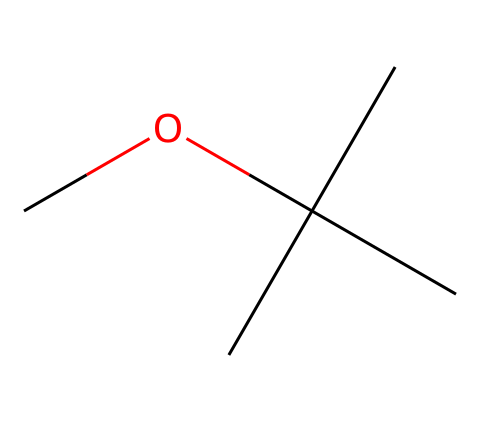What is the full name of this chemical? The SMILES representation "COC(C)(C)C" indicates a molecule with a central carbon atom connected to three other carbons and one oxygen atom. Identifying the functional group as an ether reveals it is methyl tert-butyl ether.
Answer: methyl tert-butyl ether How many carbon atoms are in this molecule? Analyzing the SMILES, there are four carbon atoms: one in the methoxy group (OCH3) and three connected to the central carbon (C(C)(C)). Therefore, a total of four carbons are present.
Answer: four What is the primary functional group here? The presence of the ether bond (R-O-R') in the structure, indicated by the oxygen bridging between carbon atoms, confirms the molecule's classification. Therefore, the primary functional group is ether.
Answer: ether What type of reaction can MTBE undergo with water? MTBE is only sparingly soluble in water due to its hydrophobic characteristics. In cases of spillage, it can lead to contamination but does not react chemically with water.
Answer: no significant reaction Is this compound considered a volatile organic compound (VOC)? MTBE has a relatively low boiling point, making it volatile and evaporative at room temperature. Its volatility classifies it as a VOC, which is a common concern in water contamination cases.
Answer: yes How could MTBE impact real estate values? The presence of MTBE in groundwater can lead to contamination fears, resulting in reduced property values, legal liabilities, and increased remediation costs. Its association with environmental risks typically decreases market attractiveness.
Answer: decreased values 